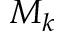<formula> <loc_0><loc_0><loc_500><loc_500>M _ { k }</formula> 